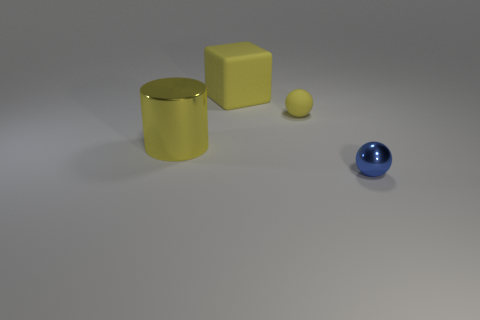Can you describe the arrangement of the objects? The objects are laid out with clear space between them, which seems intentional. From left to right, we have a small yellow object, the yellow cube, the cylinder, and the blue sphere, all placed on a flat surface. The arrangement might suggest a progression in shape complexity or an aesthetic choice for presentation. Does the composition of the image suggest any particular theme or idea? The composition, with its simplicity and clean lines, might evoke themes of order, balance, and the contrast between shapes and colors. It could represent a minimalist art piece or demonstrate principles of geometry and three-dimensionality in a straightforward yet visually appealing manner. 